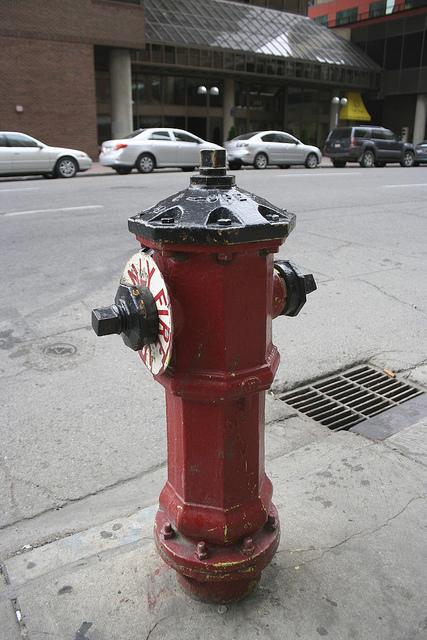What is the safety device in the foreground used to help defeat? fire 